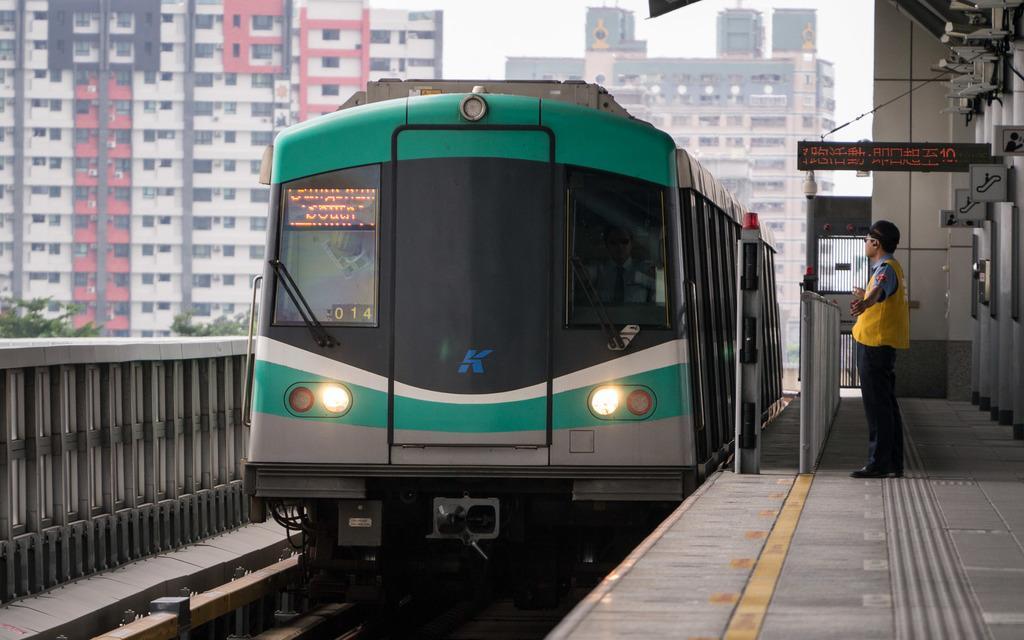In one or two sentences, can you explain what this image depicts? This is a picture taken in a railway station. On the right there are platform, railing, person, led screen, cameras, sign boards, wall, gate, lights and other objects. In the center of the picture there is a train and a railway track. On the left the trees and railing. In the background there are buildings. 